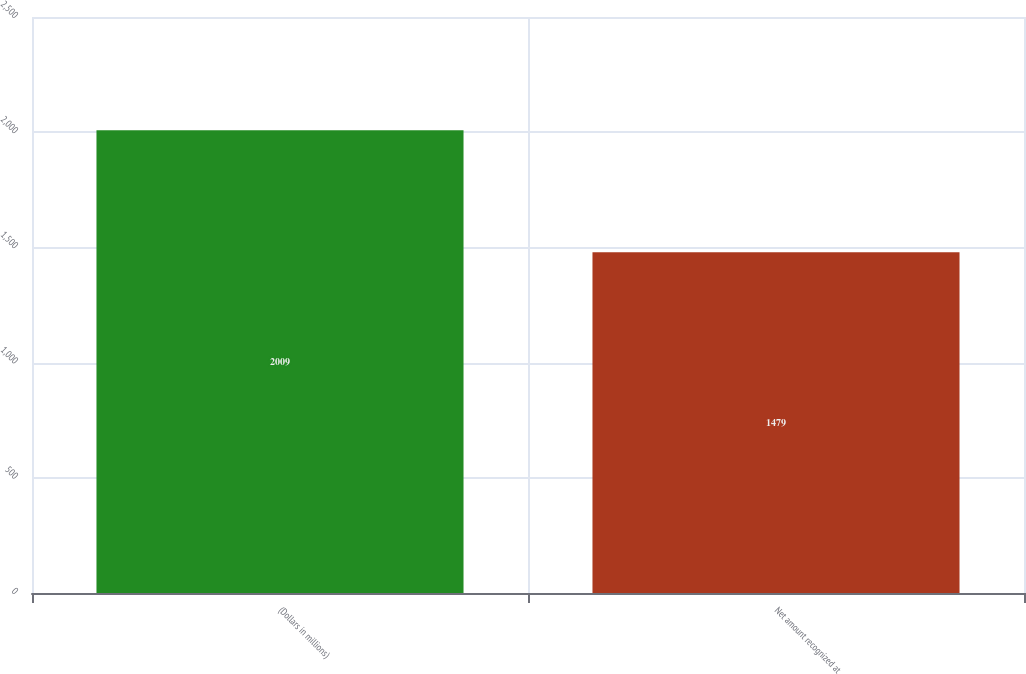Convert chart to OTSL. <chart><loc_0><loc_0><loc_500><loc_500><bar_chart><fcel>(Dollars in millions)<fcel>Net amount recognized at<nl><fcel>2009<fcel>1479<nl></chart> 